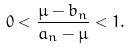<formula> <loc_0><loc_0><loc_500><loc_500>0 < \frac { \mu - b _ { n } } { a _ { n } - \mu } < 1 .</formula> 